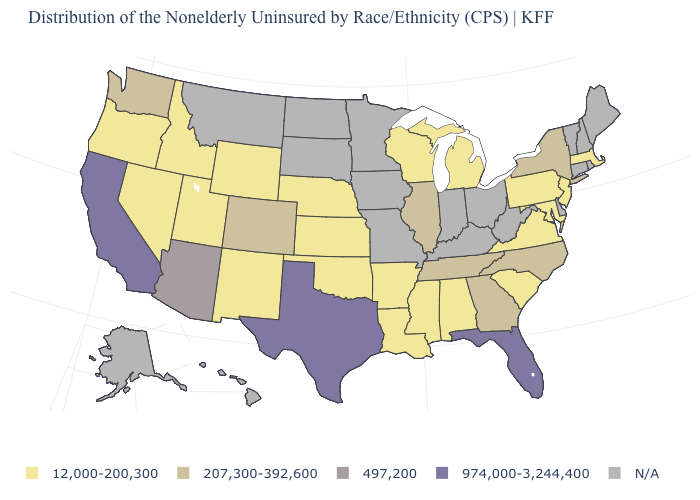Name the states that have a value in the range 12,000-200,300?
Give a very brief answer. Alabama, Arkansas, Idaho, Kansas, Louisiana, Maryland, Massachusetts, Michigan, Mississippi, Nebraska, Nevada, New Jersey, New Mexico, Oklahoma, Oregon, Pennsylvania, South Carolina, Utah, Virginia, Wisconsin, Wyoming. Name the states that have a value in the range 207,300-392,600?
Concise answer only. Colorado, Georgia, Illinois, New York, North Carolina, Tennessee, Washington. How many symbols are there in the legend?
Quick response, please. 5. What is the value of Vermont?
Write a very short answer. N/A. What is the lowest value in states that border Rhode Island?
Keep it brief. 12,000-200,300. Does the map have missing data?
Answer briefly. Yes. Name the states that have a value in the range 974,000-3,244,400?
Quick response, please. California, Florida, Texas. Name the states that have a value in the range 12,000-200,300?
Quick response, please. Alabama, Arkansas, Idaho, Kansas, Louisiana, Maryland, Massachusetts, Michigan, Mississippi, Nebraska, Nevada, New Jersey, New Mexico, Oklahoma, Oregon, Pennsylvania, South Carolina, Utah, Virginia, Wisconsin, Wyoming. Does Tennessee have the lowest value in the South?
Write a very short answer. No. Which states have the lowest value in the USA?
Short answer required. Alabama, Arkansas, Idaho, Kansas, Louisiana, Maryland, Massachusetts, Michigan, Mississippi, Nebraska, Nevada, New Jersey, New Mexico, Oklahoma, Oregon, Pennsylvania, South Carolina, Utah, Virginia, Wisconsin, Wyoming. How many symbols are there in the legend?
Concise answer only. 5. Name the states that have a value in the range 974,000-3,244,400?
Be succinct. California, Florida, Texas. Among the states that border Alabama , which have the lowest value?
Quick response, please. Mississippi. 